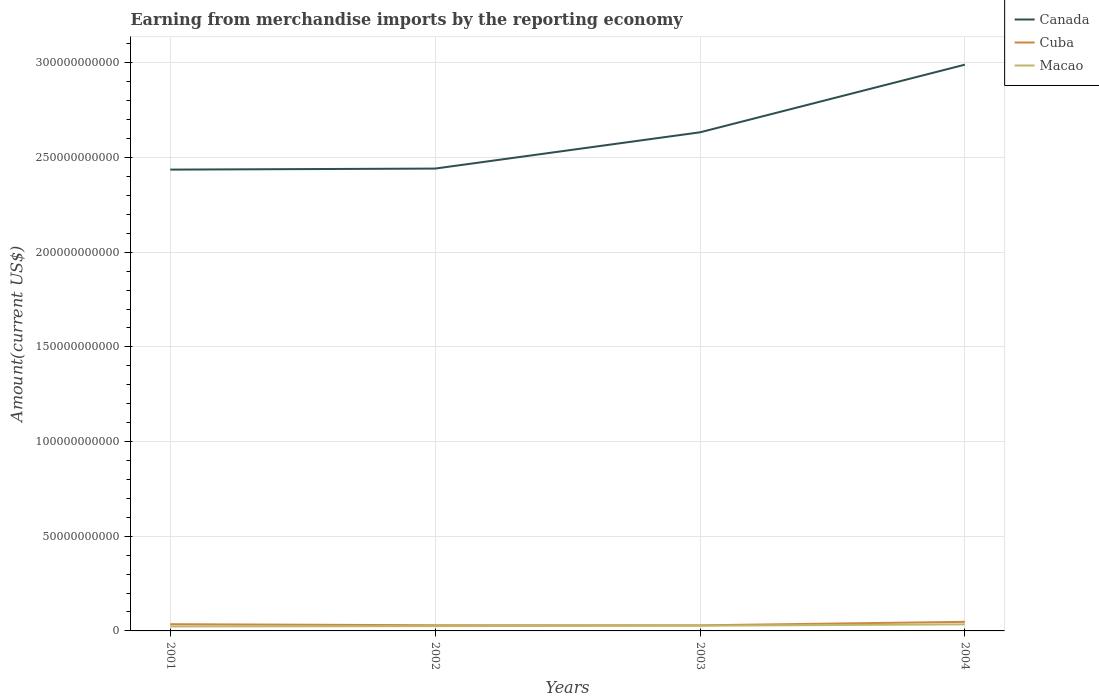How many different coloured lines are there?
Offer a very short reply. 3. Does the line corresponding to Cuba intersect with the line corresponding to Canada?
Give a very brief answer. No. Across all years, what is the maximum amount earned from merchandise imports in Cuba?
Provide a succinct answer. 2.95e+09. In which year was the amount earned from merchandise imports in Cuba maximum?
Your answer should be compact. 2003. What is the total amount earned from merchandise imports in Cuba in the graph?
Provide a succinct answer. 5.52e+08. What is the difference between the highest and the second highest amount earned from merchandise imports in Macao?
Offer a terse response. 1.09e+09. Is the amount earned from merchandise imports in Cuba strictly greater than the amount earned from merchandise imports in Canada over the years?
Offer a terse response. Yes. What is the difference between two consecutive major ticks on the Y-axis?
Your response must be concise. 5.00e+1. Are the values on the major ticks of Y-axis written in scientific E-notation?
Give a very brief answer. No. Where does the legend appear in the graph?
Your response must be concise. Top right. How many legend labels are there?
Your answer should be very brief. 3. How are the legend labels stacked?
Keep it short and to the point. Vertical. What is the title of the graph?
Provide a short and direct response. Earning from merchandise imports by the reporting economy. Does "Guinea" appear as one of the legend labels in the graph?
Provide a succinct answer. No. What is the label or title of the Y-axis?
Provide a short and direct response. Amount(current US$). What is the Amount(current US$) in Canada in 2001?
Offer a terse response. 2.44e+11. What is the Amount(current US$) of Cuba in 2001?
Your response must be concise. 3.55e+09. What is the Amount(current US$) of Macao in 2001?
Make the answer very short. 2.39e+09. What is the Amount(current US$) in Canada in 2002?
Give a very brief answer. 2.44e+11. What is the Amount(current US$) in Cuba in 2002?
Your answer should be compact. 3.00e+09. What is the Amount(current US$) of Macao in 2002?
Provide a short and direct response. 2.53e+09. What is the Amount(current US$) in Canada in 2003?
Provide a short and direct response. 2.63e+11. What is the Amount(current US$) in Cuba in 2003?
Keep it short and to the point. 2.95e+09. What is the Amount(current US$) of Macao in 2003?
Provide a succinct answer. 2.75e+09. What is the Amount(current US$) of Canada in 2004?
Offer a terse response. 2.99e+11. What is the Amount(current US$) in Cuba in 2004?
Your answer should be very brief. 4.79e+09. What is the Amount(current US$) in Macao in 2004?
Your answer should be compact. 3.48e+09. Across all years, what is the maximum Amount(current US$) in Canada?
Give a very brief answer. 2.99e+11. Across all years, what is the maximum Amount(current US$) in Cuba?
Provide a short and direct response. 4.79e+09. Across all years, what is the maximum Amount(current US$) in Macao?
Make the answer very short. 3.48e+09. Across all years, what is the minimum Amount(current US$) of Canada?
Provide a short and direct response. 2.44e+11. Across all years, what is the minimum Amount(current US$) in Cuba?
Ensure brevity in your answer.  2.95e+09. Across all years, what is the minimum Amount(current US$) in Macao?
Your answer should be very brief. 2.39e+09. What is the total Amount(current US$) of Canada in the graph?
Offer a terse response. 1.05e+12. What is the total Amount(current US$) in Cuba in the graph?
Keep it short and to the point. 1.43e+1. What is the total Amount(current US$) in Macao in the graph?
Make the answer very short. 1.11e+1. What is the difference between the Amount(current US$) in Canada in 2001 and that in 2002?
Provide a short and direct response. -5.42e+08. What is the difference between the Amount(current US$) of Cuba in 2001 and that in 2002?
Provide a short and direct response. 5.52e+08. What is the difference between the Amount(current US$) in Macao in 2001 and that in 2002?
Offer a terse response. -1.43e+08. What is the difference between the Amount(current US$) of Canada in 2001 and that in 2003?
Your answer should be compact. -1.97e+1. What is the difference between the Amount(current US$) of Cuba in 2001 and that in 2003?
Provide a short and direct response. 5.96e+08. What is the difference between the Amount(current US$) in Macao in 2001 and that in 2003?
Offer a very short reply. -3.60e+08. What is the difference between the Amount(current US$) in Canada in 2001 and that in 2004?
Provide a succinct answer. -5.54e+1. What is the difference between the Amount(current US$) of Cuba in 2001 and that in 2004?
Keep it short and to the point. -1.24e+09. What is the difference between the Amount(current US$) in Macao in 2001 and that in 2004?
Give a very brief answer. -1.09e+09. What is the difference between the Amount(current US$) of Canada in 2002 and that in 2003?
Offer a very short reply. -1.92e+1. What is the difference between the Amount(current US$) in Cuba in 2002 and that in 2003?
Ensure brevity in your answer.  4.44e+07. What is the difference between the Amount(current US$) in Macao in 2002 and that in 2003?
Offer a very short reply. -2.17e+08. What is the difference between the Amount(current US$) of Canada in 2002 and that in 2004?
Make the answer very short. -5.49e+1. What is the difference between the Amount(current US$) in Cuba in 2002 and that in 2004?
Your response must be concise. -1.79e+09. What is the difference between the Amount(current US$) in Macao in 2002 and that in 2004?
Ensure brevity in your answer.  -9.48e+08. What is the difference between the Amount(current US$) in Canada in 2003 and that in 2004?
Provide a short and direct response. -3.57e+1. What is the difference between the Amount(current US$) of Cuba in 2003 and that in 2004?
Your response must be concise. -1.84e+09. What is the difference between the Amount(current US$) of Macao in 2003 and that in 2004?
Offer a terse response. -7.31e+08. What is the difference between the Amount(current US$) in Canada in 2001 and the Amount(current US$) in Cuba in 2002?
Your answer should be very brief. 2.41e+11. What is the difference between the Amount(current US$) of Canada in 2001 and the Amount(current US$) of Macao in 2002?
Your response must be concise. 2.41e+11. What is the difference between the Amount(current US$) in Cuba in 2001 and the Amount(current US$) in Macao in 2002?
Offer a very short reply. 1.02e+09. What is the difference between the Amount(current US$) in Canada in 2001 and the Amount(current US$) in Cuba in 2003?
Offer a terse response. 2.41e+11. What is the difference between the Amount(current US$) in Canada in 2001 and the Amount(current US$) in Macao in 2003?
Make the answer very short. 2.41e+11. What is the difference between the Amount(current US$) in Cuba in 2001 and the Amount(current US$) in Macao in 2003?
Provide a succinct answer. 8.05e+08. What is the difference between the Amount(current US$) of Canada in 2001 and the Amount(current US$) of Cuba in 2004?
Your answer should be very brief. 2.39e+11. What is the difference between the Amount(current US$) in Canada in 2001 and the Amount(current US$) in Macao in 2004?
Ensure brevity in your answer.  2.40e+11. What is the difference between the Amount(current US$) of Cuba in 2001 and the Amount(current US$) of Macao in 2004?
Your answer should be compact. 7.34e+07. What is the difference between the Amount(current US$) of Canada in 2002 and the Amount(current US$) of Cuba in 2003?
Offer a terse response. 2.41e+11. What is the difference between the Amount(current US$) of Canada in 2002 and the Amount(current US$) of Macao in 2003?
Keep it short and to the point. 2.41e+11. What is the difference between the Amount(current US$) in Cuba in 2002 and the Amount(current US$) in Macao in 2003?
Ensure brevity in your answer.  2.53e+08. What is the difference between the Amount(current US$) in Canada in 2002 and the Amount(current US$) in Cuba in 2004?
Keep it short and to the point. 2.39e+11. What is the difference between the Amount(current US$) in Canada in 2002 and the Amount(current US$) in Macao in 2004?
Provide a short and direct response. 2.41e+11. What is the difference between the Amount(current US$) of Cuba in 2002 and the Amount(current US$) of Macao in 2004?
Offer a terse response. -4.79e+08. What is the difference between the Amount(current US$) of Canada in 2003 and the Amount(current US$) of Cuba in 2004?
Your answer should be compact. 2.59e+11. What is the difference between the Amount(current US$) in Canada in 2003 and the Amount(current US$) in Macao in 2004?
Give a very brief answer. 2.60e+11. What is the difference between the Amount(current US$) in Cuba in 2003 and the Amount(current US$) in Macao in 2004?
Provide a short and direct response. -5.23e+08. What is the average Amount(current US$) of Canada per year?
Provide a succinct answer. 2.63e+11. What is the average Amount(current US$) in Cuba per year?
Give a very brief answer. 3.57e+09. What is the average Amount(current US$) in Macao per year?
Provide a short and direct response. 2.79e+09. In the year 2001, what is the difference between the Amount(current US$) of Canada and Amount(current US$) of Cuba?
Your answer should be very brief. 2.40e+11. In the year 2001, what is the difference between the Amount(current US$) in Canada and Amount(current US$) in Macao?
Provide a short and direct response. 2.41e+11. In the year 2001, what is the difference between the Amount(current US$) of Cuba and Amount(current US$) of Macao?
Make the answer very short. 1.16e+09. In the year 2002, what is the difference between the Amount(current US$) of Canada and Amount(current US$) of Cuba?
Make the answer very short. 2.41e+11. In the year 2002, what is the difference between the Amount(current US$) of Canada and Amount(current US$) of Macao?
Provide a succinct answer. 2.42e+11. In the year 2002, what is the difference between the Amount(current US$) of Cuba and Amount(current US$) of Macao?
Make the answer very short. 4.70e+08. In the year 2003, what is the difference between the Amount(current US$) in Canada and Amount(current US$) in Cuba?
Offer a terse response. 2.60e+11. In the year 2003, what is the difference between the Amount(current US$) in Canada and Amount(current US$) in Macao?
Your answer should be compact. 2.61e+11. In the year 2003, what is the difference between the Amount(current US$) in Cuba and Amount(current US$) in Macao?
Make the answer very short. 2.08e+08. In the year 2004, what is the difference between the Amount(current US$) of Canada and Amount(current US$) of Cuba?
Offer a very short reply. 2.94e+11. In the year 2004, what is the difference between the Amount(current US$) in Canada and Amount(current US$) in Macao?
Offer a very short reply. 2.96e+11. In the year 2004, what is the difference between the Amount(current US$) in Cuba and Amount(current US$) in Macao?
Make the answer very short. 1.31e+09. What is the ratio of the Amount(current US$) in Cuba in 2001 to that in 2002?
Ensure brevity in your answer.  1.18. What is the ratio of the Amount(current US$) of Macao in 2001 to that in 2002?
Your response must be concise. 0.94. What is the ratio of the Amount(current US$) in Canada in 2001 to that in 2003?
Give a very brief answer. 0.93. What is the ratio of the Amount(current US$) in Cuba in 2001 to that in 2003?
Give a very brief answer. 1.2. What is the ratio of the Amount(current US$) of Macao in 2001 to that in 2003?
Your answer should be compact. 0.87. What is the ratio of the Amount(current US$) of Canada in 2001 to that in 2004?
Offer a very short reply. 0.81. What is the ratio of the Amount(current US$) in Cuba in 2001 to that in 2004?
Keep it short and to the point. 0.74. What is the ratio of the Amount(current US$) of Macao in 2001 to that in 2004?
Ensure brevity in your answer.  0.69. What is the ratio of the Amount(current US$) in Canada in 2002 to that in 2003?
Your response must be concise. 0.93. What is the ratio of the Amount(current US$) of Macao in 2002 to that in 2003?
Offer a very short reply. 0.92. What is the ratio of the Amount(current US$) in Canada in 2002 to that in 2004?
Keep it short and to the point. 0.82. What is the ratio of the Amount(current US$) in Cuba in 2002 to that in 2004?
Offer a very short reply. 0.63. What is the ratio of the Amount(current US$) of Macao in 2002 to that in 2004?
Your answer should be compact. 0.73. What is the ratio of the Amount(current US$) in Canada in 2003 to that in 2004?
Provide a succinct answer. 0.88. What is the ratio of the Amount(current US$) of Cuba in 2003 to that in 2004?
Offer a terse response. 0.62. What is the ratio of the Amount(current US$) in Macao in 2003 to that in 2004?
Make the answer very short. 0.79. What is the difference between the highest and the second highest Amount(current US$) of Canada?
Your response must be concise. 3.57e+1. What is the difference between the highest and the second highest Amount(current US$) in Cuba?
Your answer should be compact. 1.24e+09. What is the difference between the highest and the second highest Amount(current US$) in Macao?
Provide a short and direct response. 7.31e+08. What is the difference between the highest and the lowest Amount(current US$) in Canada?
Keep it short and to the point. 5.54e+1. What is the difference between the highest and the lowest Amount(current US$) in Cuba?
Your answer should be very brief. 1.84e+09. What is the difference between the highest and the lowest Amount(current US$) in Macao?
Your response must be concise. 1.09e+09. 